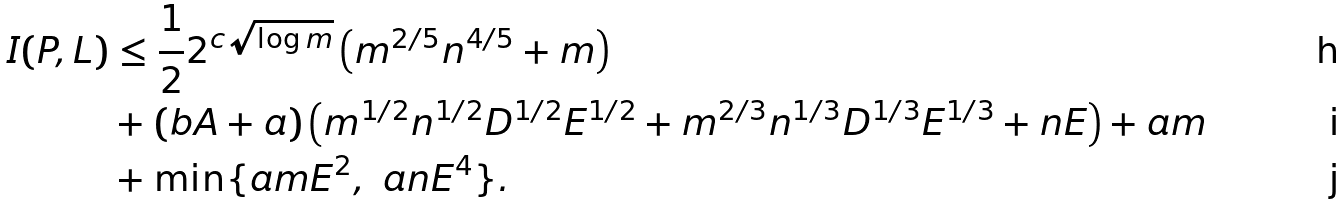<formula> <loc_0><loc_0><loc_500><loc_500>I ( P , L ) & \leq \frac { 1 } { 2 } 2 ^ { c \sqrt { \log m } } \left ( m ^ { 2 / 5 } n ^ { 4 / 5 } + m \right ) \\ & + ( b A + a ) \left ( m ^ { 1 / 2 } n ^ { 1 / 2 } D ^ { 1 / 2 } E ^ { 1 / 2 } + m ^ { 2 / 3 } n ^ { 1 / 3 } D ^ { 1 / 3 } E ^ { 1 / 3 } + n E \right ) + a m \\ & + \min \{ a m E ^ { 2 } , \ a n E ^ { 4 } \} .</formula> 